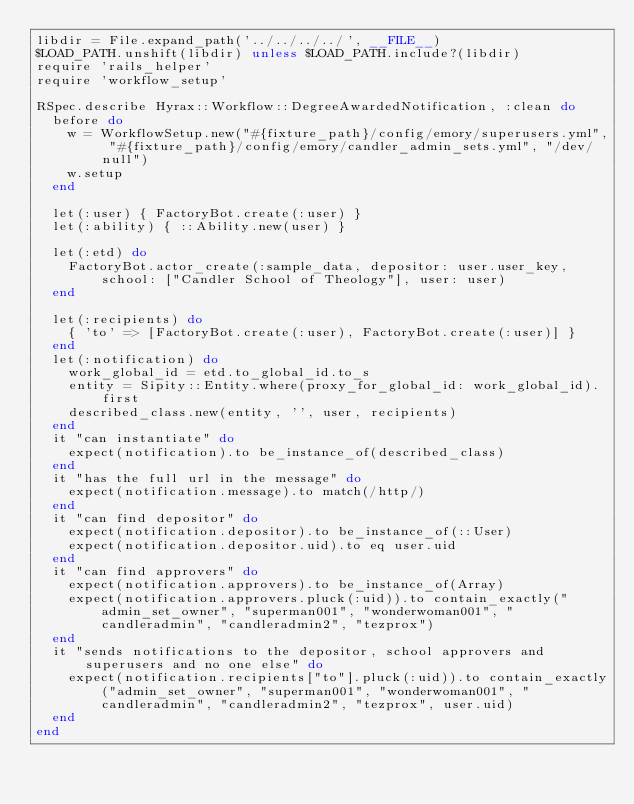<code> <loc_0><loc_0><loc_500><loc_500><_Ruby_>libdir = File.expand_path('../../../../', __FILE__)
$LOAD_PATH.unshift(libdir) unless $LOAD_PATH.include?(libdir)
require 'rails_helper'
require 'workflow_setup'

RSpec.describe Hyrax::Workflow::DegreeAwardedNotification, :clean do
  before do
    w = WorkflowSetup.new("#{fixture_path}/config/emory/superusers.yml", "#{fixture_path}/config/emory/candler_admin_sets.yml", "/dev/null")
    w.setup
  end

  let(:user) { FactoryBot.create(:user) }
  let(:ability) { ::Ability.new(user) }

  let(:etd) do
    FactoryBot.actor_create(:sample_data, depositor: user.user_key, school: ["Candler School of Theology"], user: user)
  end

  let(:recipients) do
    { 'to' => [FactoryBot.create(:user), FactoryBot.create(:user)] }
  end
  let(:notification) do
    work_global_id = etd.to_global_id.to_s
    entity = Sipity::Entity.where(proxy_for_global_id: work_global_id).first
    described_class.new(entity, '', user, recipients)
  end
  it "can instantiate" do
    expect(notification).to be_instance_of(described_class)
  end
  it "has the full url in the message" do
    expect(notification.message).to match(/http/)
  end
  it "can find depositor" do
    expect(notification.depositor).to be_instance_of(::User)
    expect(notification.depositor.uid).to eq user.uid
  end
  it "can find approvers" do
    expect(notification.approvers).to be_instance_of(Array)
    expect(notification.approvers.pluck(:uid)).to contain_exactly("admin_set_owner", "superman001", "wonderwoman001", "candleradmin", "candleradmin2", "tezprox")
  end
  it "sends notifications to the depositor, school approvers and superusers and no one else" do
    expect(notification.recipients["to"].pluck(:uid)).to contain_exactly("admin_set_owner", "superman001", "wonderwoman001", "candleradmin", "candleradmin2", "tezprox", user.uid)
  end
end
</code> 